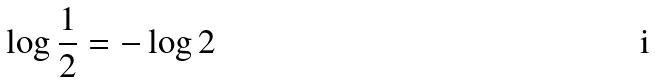Convert formula to latex. <formula><loc_0><loc_0><loc_500><loc_500>\log \frac { 1 } { 2 } = - \log 2</formula> 